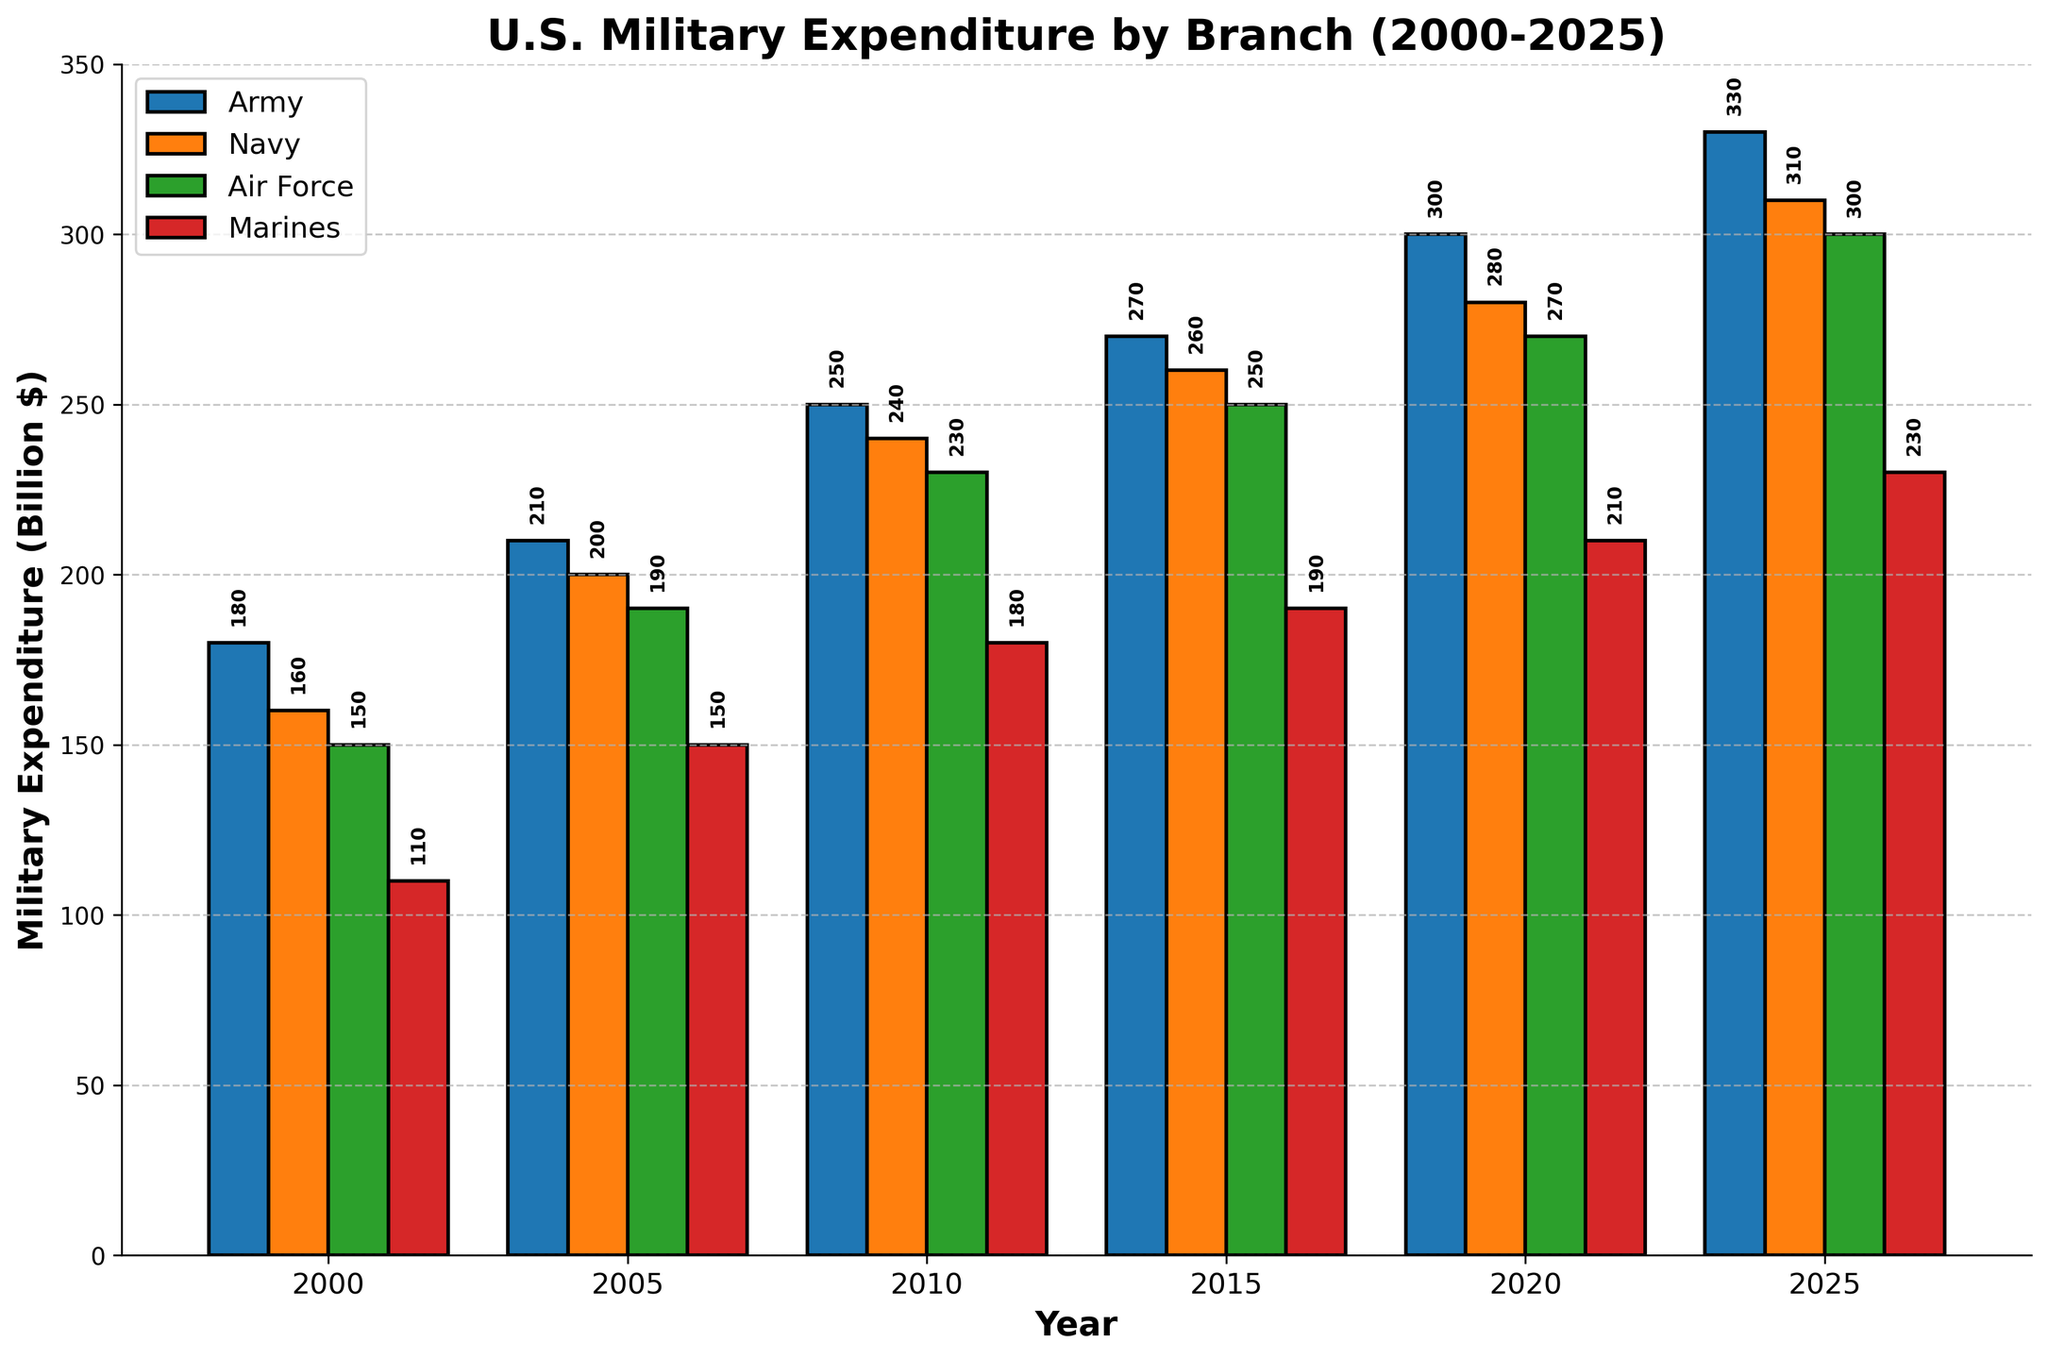What is the title of the figure? The title is displayed at the top of the figure and describes what the whole figure is about.
Answer: U.S. Military Expenditure by Branch (2000-2025) What is the expenditure for the Navy in 2010? Look at the bar corresponding to the Navy in the year 2010; it's about halfway between 200 and 300. The exact value is displayed above the bar.
Answer: 240 How much did the expenditure for the Army increase from 2000 to 2020? Find the Army's expenditure in both 2000 and 2020, then subtract the 2000 value from the 2020 value. The values are labeled directly above the bars.
Answer: 120 Among the branches, which had the highest expenditure in 2025? Compare the heights of the bars for each branch in 2025. The highest bar represents the branch with the highest expenditure.
Answer: Army Which branch has the lowest expenditure increase from 2000 to 2025? Calculate the increases for each branch by subtracting their 2000 values from their 2025 values. The branch with the smallest difference has the lowest increase.
Answer: Marines What is the average military expenditure for the Air Force over the entire period? Find the expenditure for the Air Force for each year, sum them, and then divide by the number of years (6 years). Values are labeled above the bars.
Answer: 231.67 Compare the expenditure of the Army and the Navy in 2015. Which one is higher and by how much? Look at the bars for the Army and Navy in 2015, then subtract the Navy's value from the Army's value to find the difference.
Answer: Army is higher by 10 What was the total military expenditure for all branches together in 2010? Add the expenditures for all branches in 2010. The values are displayed above the bars.
Answer: 900 Do all branches show a consistent increase in expenditure from 2000 to 2025? Check each branch's expenditure in 2000 and compare it sequentially to 2005, 2010, 2015, 2020, and 2025 to see if there's a consistent increase.
Answer: Yes Which years showed the largest absolute increase in Army expenditure compared to the previous year? Calculate the difference in Army expenditure between each pair of consecutive years. Identify the pair with the largest difference.
Answer: 2020 to 2025 